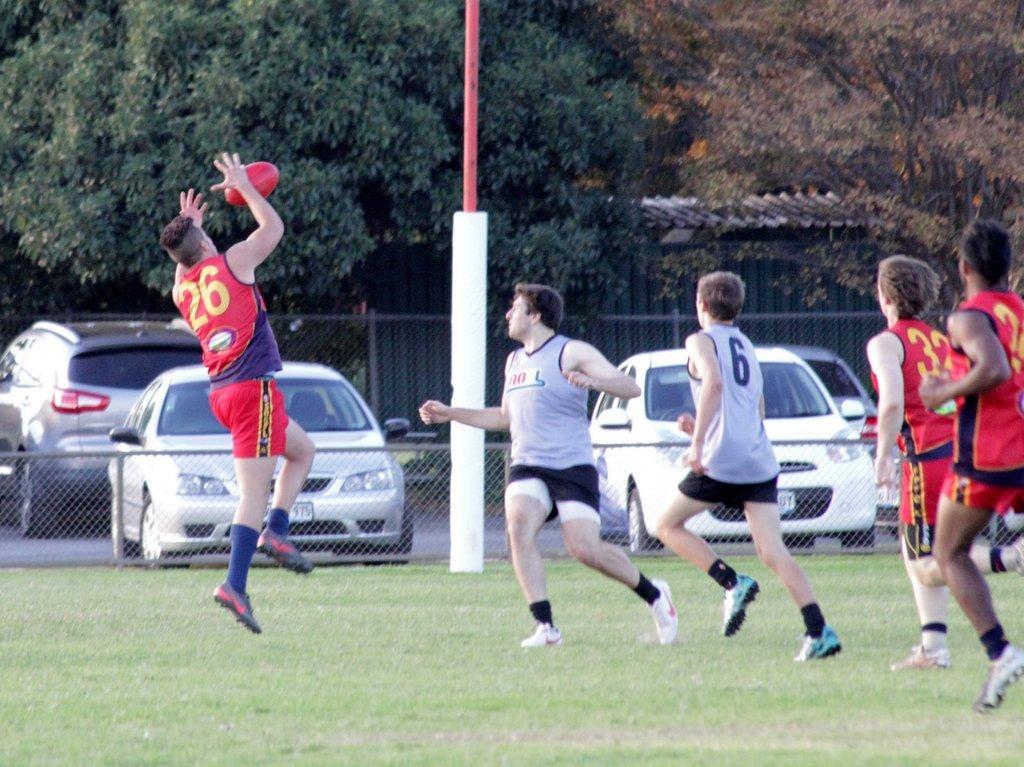Could you give a brief overview of what you see in this image? In this image I can see the group of people on the ground. I can see the ball in the air. In the background I can see the railing, few vehicles on the road, shed and many trees. 